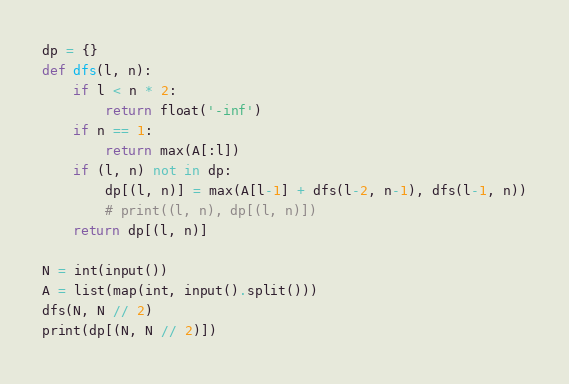Convert code to text. <code><loc_0><loc_0><loc_500><loc_500><_Python_>dp = {}
def dfs(l, n):
    if l < n * 2:
        return float('-inf')
    if n == 1:
        return max(A[:l])
    if (l, n) not in dp:
        dp[(l, n)] = max(A[l-1] + dfs(l-2, n-1), dfs(l-1, n))
        # print((l, n), dp[(l, n)])
    return dp[(l, n)]

N = int(input())
A = list(map(int, input().split()))
dfs(N, N // 2)
print(dp[(N, N // 2)])</code> 